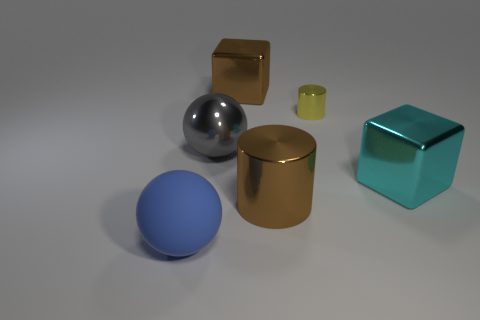What color is the small cylinder that is made of the same material as the cyan block?
Your response must be concise. Yellow. What number of cyan metal objects have the same size as the blue rubber ball?
Your answer should be compact. 1. What number of red things are large objects or tiny metallic objects?
Your response must be concise. 0. How many things are blue matte blocks or big spheres that are behind the big cylinder?
Provide a succinct answer. 1. What is the material of the object that is on the left side of the shiny ball?
Your answer should be compact. Rubber. What shape is the cyan metal thing that is the same size as the rubber sphere?
Your response must be concise. Cube. Is there a small blue matte thing of the same shape as the big gray object?
Provide a succinct answer. No. Do the big gray thing and the large blue ball left of the yellow metal cylinder have the same material?
Your answer should be compact. No. There is a ball that is in front of the big block that is on the right side of the large brown cube; what is its material?
Your answer should be compact. Rubber. Is the number of small objects that are behind the large brown shiny block greater than the number of things?
Offer a terse response. No. 